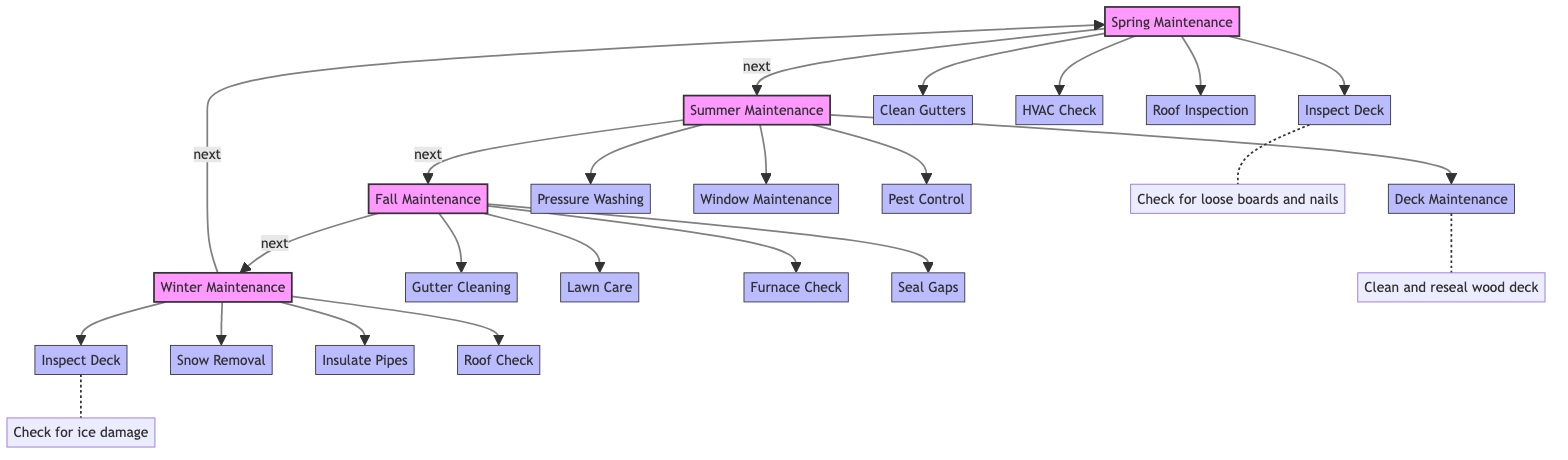What is the first maintenance task listed for Spring? According to the diagram, the first task in the Spring section is "Inspect Deck". This is the first arrow leading out from the Spring node to a task node.
Answer: Inspect Deck How many tasks are shown in the Summer maintenance section? In the Summer section, there are four task nodes: "Deck Maintenance", "Pressure Washing", "Window Maintenance", and "Pest Control". Counting these gives a total of four tasks in Summer.
Answer: 4 What task is listed under Winter maintenance that is also in Spring? The diagram shows "Inspect Deck" as a task in both Spring and Winter maintenance sections. By comparing the tasks in each season, it's clear this task recurs twice.
Answer: Inspect Deck Which season features the task "Gutter Cleaning"? The task "Gutter Cleaning" is found in the Fall maintenance section. This can be determined by looking for this specific task within the associated tasks of each season.
Answer: Fall What is the final task listed in the Fall section? The last task in the Fall section is "Seal Gaps". By following the flow in the Fall section from the first to the last task, this is identified as the last node.
Answer: Seal Gaps Which task requires checking for ice damage? The task "Inspect Deck" in the Winter maintenance section has a note that specifies checking for ice damage. This is noted as a specific detail connected to the Winter task node.
Answer: Check for ice damage How many seasonal sections are included in the diagram? The diagram includes four seasonal sections: Spring, Summer, Fall, and Winter. Counting the main sections leads to the conclusion of four distinct seasonal areas.
Answer: 4 What is the relationship between Summer and Fall in the flowchart? Summer leads directly into Fall, indicated by the "next" arrow connecting these two sections. This shows the progression from summer tasks to fall tasks.
Answer: next What is the first Spring task that follows the "next" relationship? Following the "next" arrow from Spring, the first task listed is "Inspect Deck". This is directly connected to the Spring node.
Answer: Inspect Deck 